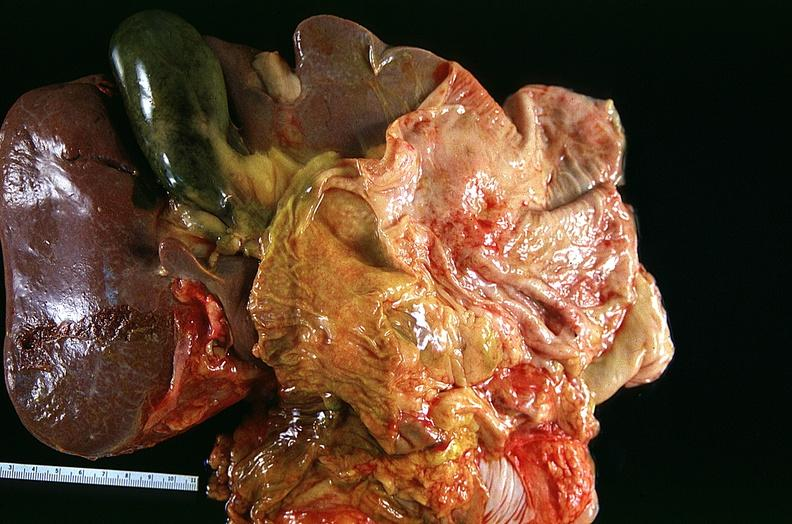where is this?
Answer the question using a single word or phrase. Lung 